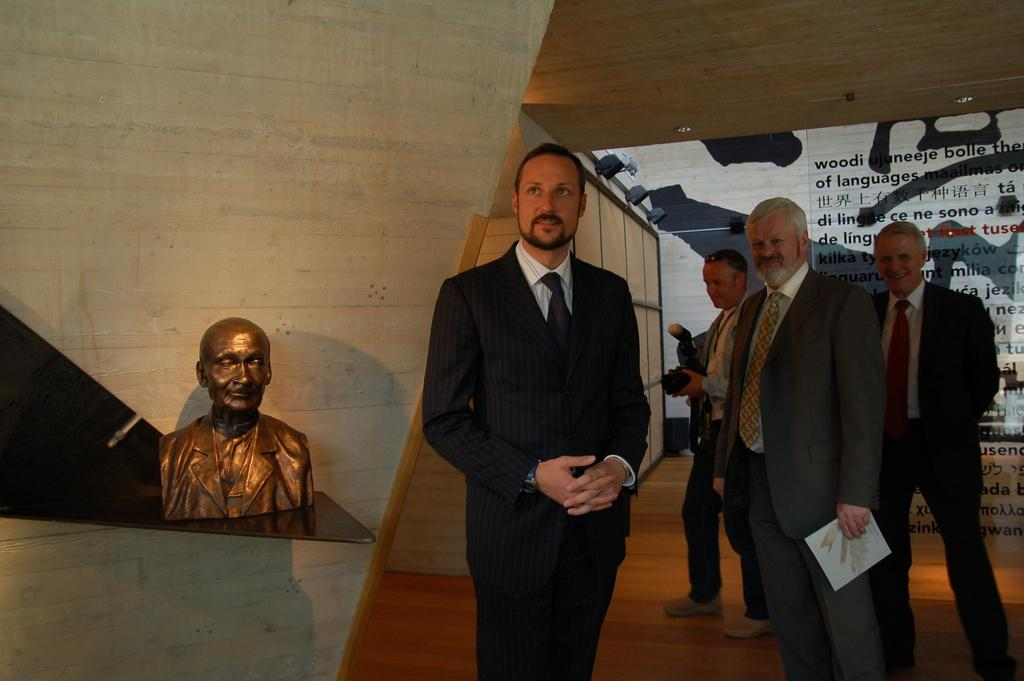Who or what can be seen in the image? There are people in the image. What is the main artistic feature in the image? There is a sculpture in the image. What else can be seen in the image besides the people and sculpture? There are other objects in the image. What can be seen in the background of the image? There is a wall and a board in the background of the image, along with other objects. What degree of temperature can be felt from the veins in the image? There are no veins present in the image, and therefore no temperature can be associated with them. 